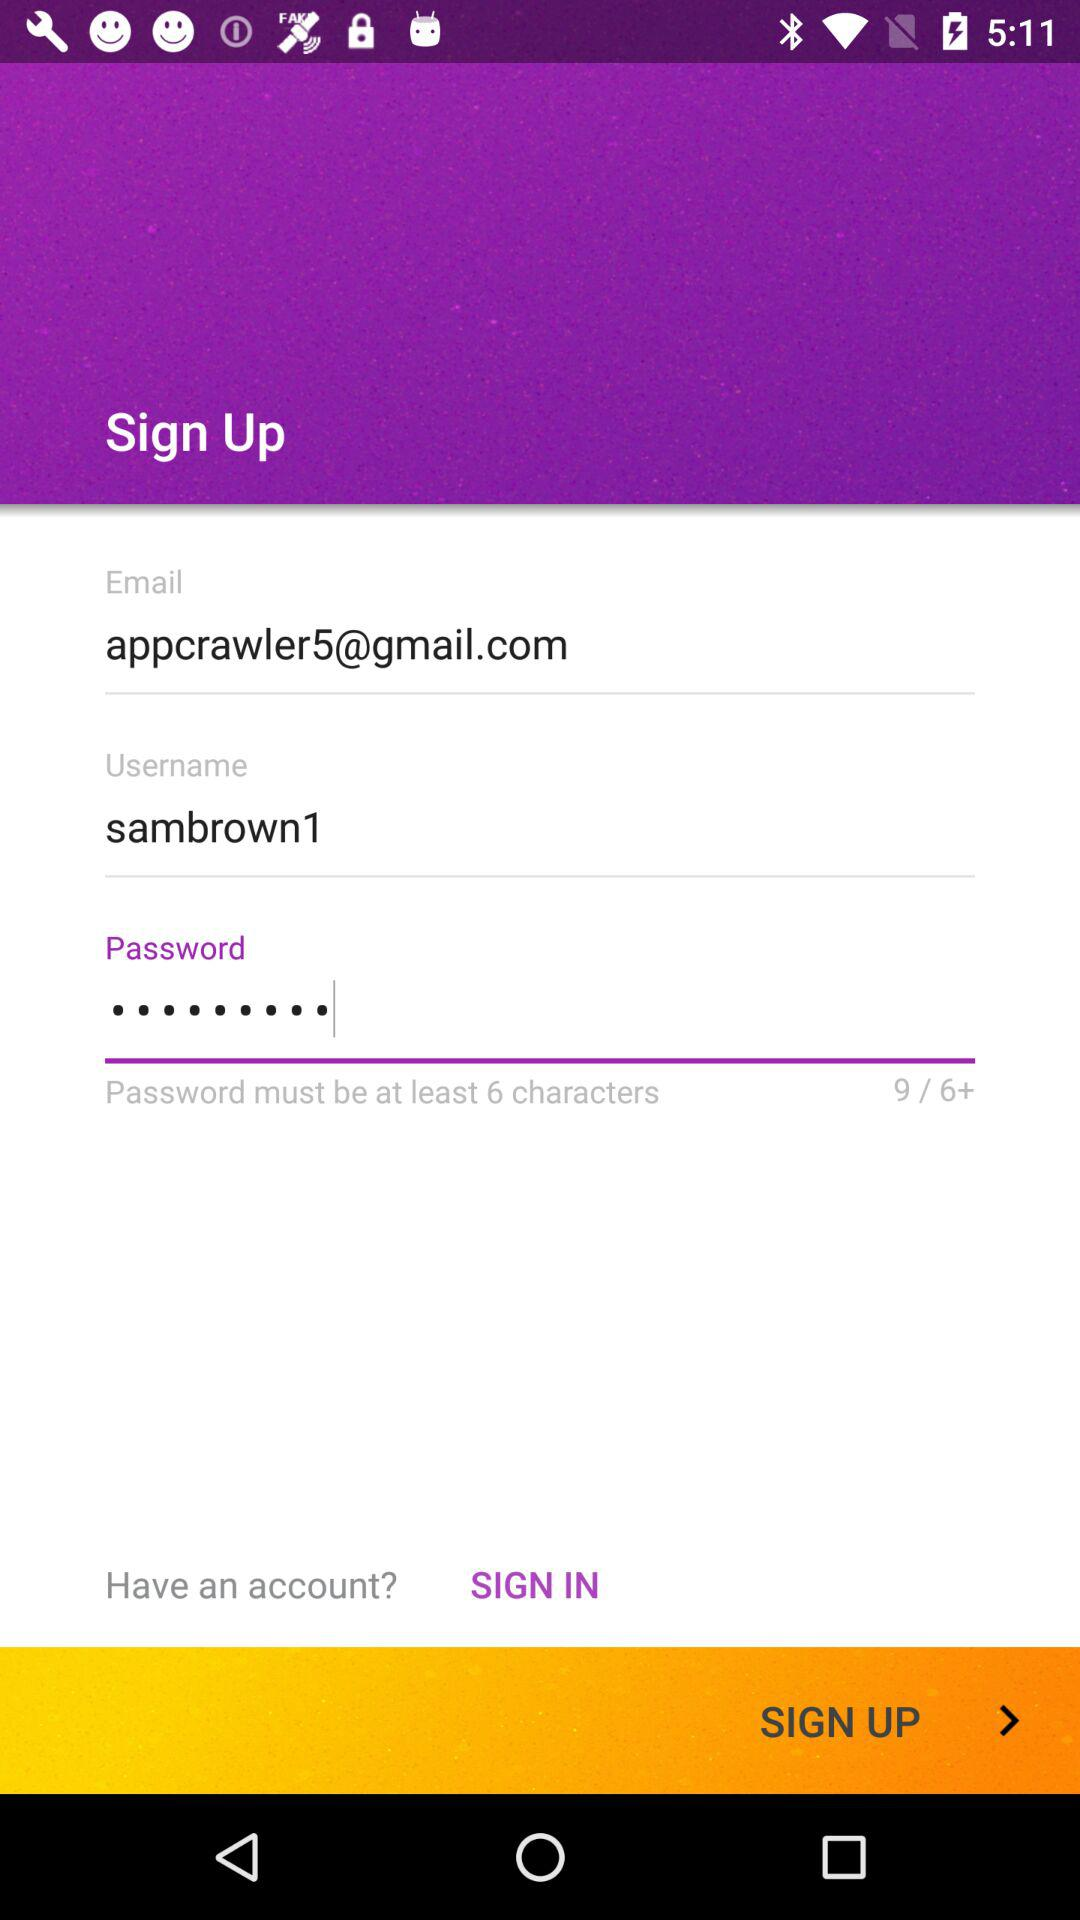What is the username? The username is "sambrown1". 